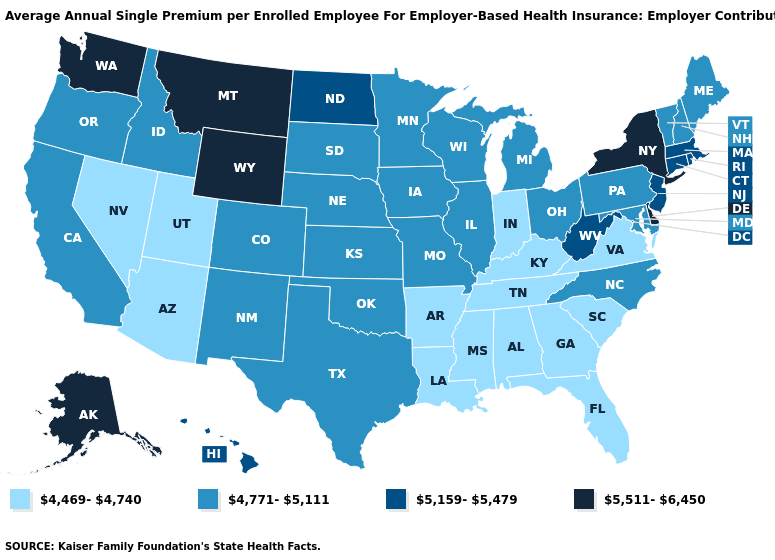Does Delaware have the highest value in the USA?
Keep it brief. Yes. Name the states that have a value in the range 5,511-6,450?
Quick response, please. Alaska, Delaware, Montana, New York, Washington, Wyoming. What is the lowest value in the South?
Write a very short answer. 4,469-4,740. What is the value of Hawaii?
Give a very brief answer. 5,159-5,479. Name the states that have a value in the range 4,771-5,111?
Write a very short answer. California, Colorado, Idaho, Illinois, Iowa, Kansas, Maine, Maryland, Michigan, Minnesota, Missouri, Nebraska, New Hampshire, New Mexico, North Carolina, Ohio, Oklahoma, Oregon, Pennsylvania, South Dakota, Texas, Vermont, Wisconsin. Name the states that have a value in the range 4,469-4,740?
Concise answer only. Alabama, Arizona, Arkansas, Florida, Georgia, Indiana, Kentucky, Louisiana, Mississippi, Nevada, South Carolina, Tennessee, Utah, Virginia. Which states have the lowest value in the Northeast?
Concise answer only. Maine, New Hampshire, Pennsylvania, Vermont. Does Nevada have the lowest value in the West?
Keep it brief. Yes. Name the states that have a value in the range 4,469-4,740?
Keep it brief. Alabama, Arizona, Arkansas, Florida, Georgia, Indiana, Kentucky, Louisiana, Mississippi, Nevada, South Carolina, Tennessee, Utah, Virginia. Name the states that have a value in the range 4,469-4,740?
Quick response, please. Alabama, Arizona, Arkansas, Florida, Georgia, Indiana, Kentucky, Louisiana, Mississippi, Nevada, South Carolina, Tennessee, Utah, Virginia. What is the lowest value in the West?
Give a very brief answer. 4,469-4,740. Name the states that have a value in the range 5,511-6,450?
Concise answer only. Alaska, Delaware, Montana, New York, Washington, Wyoming. What is the value of Washington?
Answer briefly. 5,511-6,450. What is the value of Texas?
Write a very short answer. 4,771-5,111. 